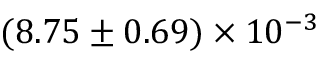<formula> <loc_0><loc_0><loc_500><loc_500>( 8 . 7 5 \pm 0 . 6 9 ) \times 1 0 ^ { - 3 }</formula> 